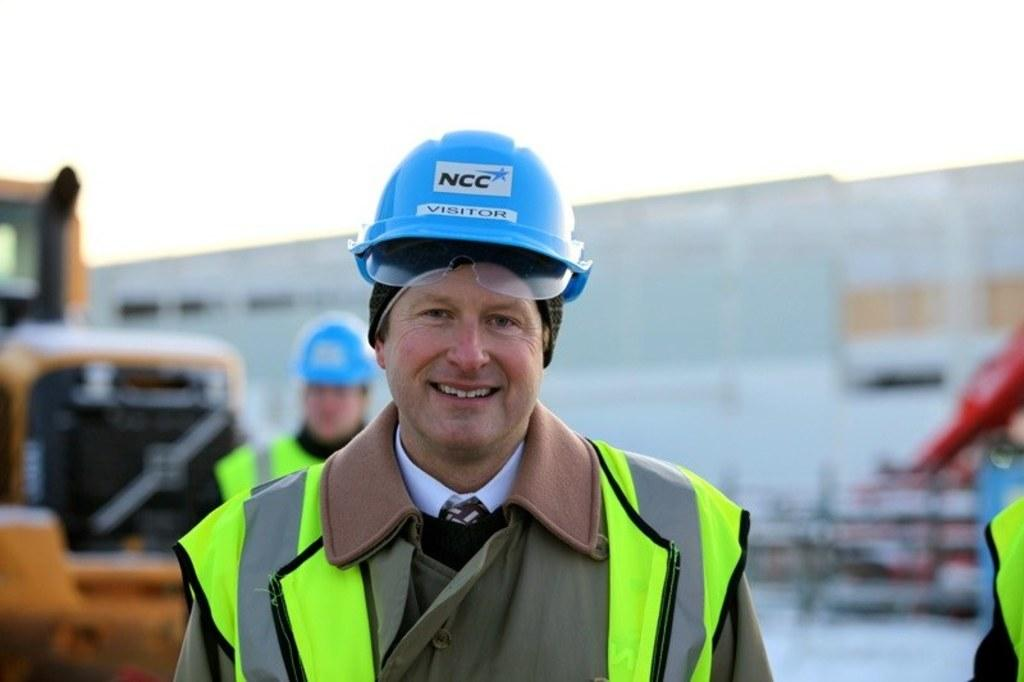Who is present in the image? There is a man in the image. What is the man wearing on his upper body? The man is wearing a green jacket. What type of headgear is the man wearing? The man is wearing a blue helmet. What can be seen on the left side of the image? There is a vehicle on the left side of the image. What is visible in the background of the image? There is a wall in the background of the image. What is visible at the top of the image? The sky is visible at the top of the image. Where are the ducks swimming in the image? There are no ducks present in the image. What type of ice can be seen melting on the vehicle in the image? There is no ice present on the vehicle in the image. 